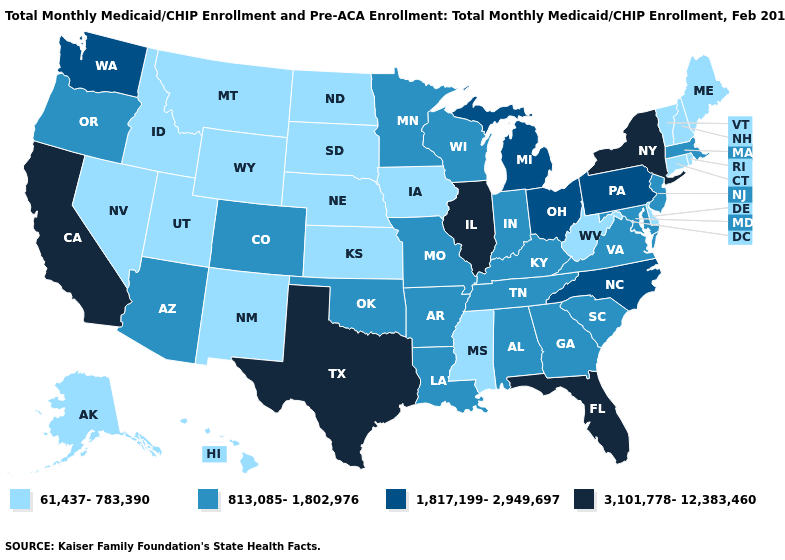Name the states that have a value in the range 61,437-783,390?
Concise answer only. Alaska, Connecticut, Delaware, Hawaii, Idaho, Iowa, Kansas, Maine, Mississippi, Montana, Nebraska, Nevada, New Hampshire, New Mexico, North Dakota, Rhode Island, South Dakota, Utah, Vermont, West Virginia, Wyoming. Name the states that have a value in the range 813,085-1,802,976?
Quick response, please. Alabama, Arizona, Arkansas, Colorado, Georgia, Indiana, Kentucky, Louisiana, Maryland, Massachusetts, Minnesota, Missouri, New Jersey, Oklahoma, Oregon, South Carolina, Tennessee, Virginia, Wisconsin. What is the value of Massachusetts?
Concise answer only. 813,085-1,802,976. Does Nebraska have the highest value in the USA?
Give a very brief answer. No. What is the value of Missouri?
Keep it brief. 813,085-1,802,976. What is the value of Delaware?
Concise answer only. 61,437-783,390. Name the states that have a value in the range 61,437-783,390?
Answer briefly. Alaska, Connecticut, Delaware, Hawaii, Idaho, Iowa, Kansas, Maine, Mississippi, Montana, Nebraska, Nevada, New Hampshire, New Mexico, North Dakota, Rhode Island, South Dakota, Utah, Vermont, West Virginia, Wyoming. What is the value of Florida?
Answer briefly. 3,101,778-12,383,460. Does the first symbol in the legend represent the smallest category?
Give a very brief answer. Yes. Does North Dakota have a higher value than Florida?
Answer briefly. No. What is the lowest value in the MidWest?
Quick response, please. 61,437-783,390. What is the value of South Dakota?
Be succinct. 61,437-783,390. What is the value of Connecticut?
Be succinct. 61,437-783,390. Name the states that have a value in the range 1,817,199-2,949,697?
Give a very brief answer. Michigan, North Carolina, Ohio, Pennsylvania, Washington. What is the lowest value in the Northeast?
Concise answer only. 61,437-783,390. 